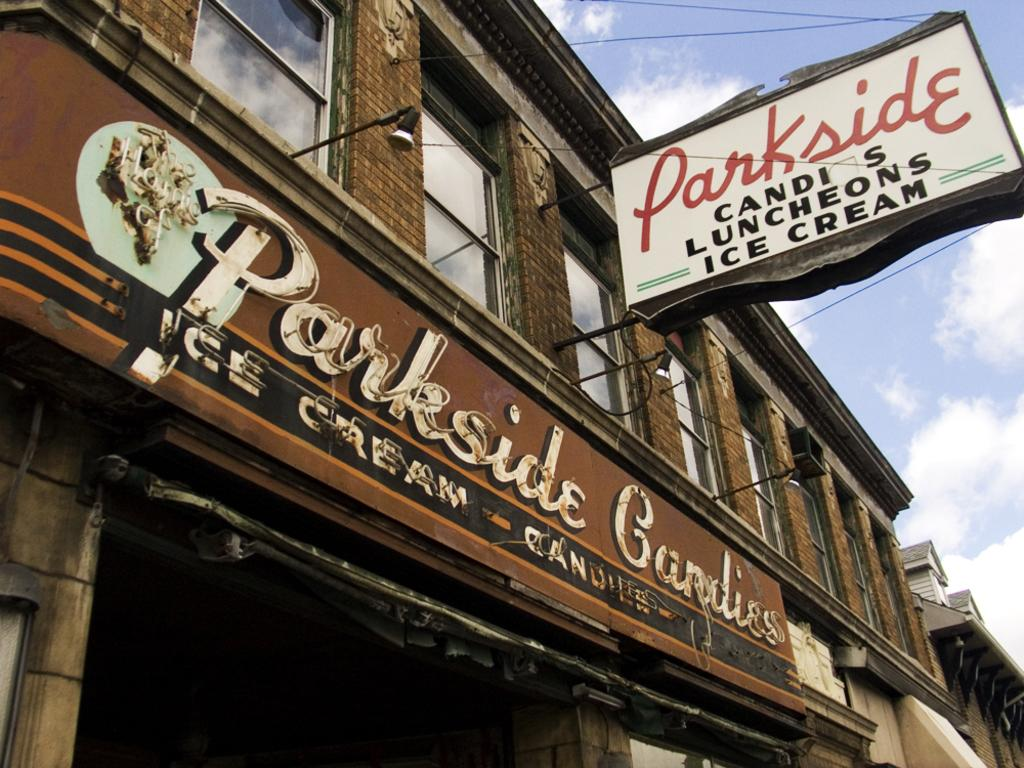What type of structures can be seen in the image? There are buildings in the image. Can you describe a specific building in the image? There is a building with windows in the image. What is attached to the building? There are posters attached to the building. How are the posters in the image? The posters are highlighted. What is visible in the background of the image? The sky is visible in the image. What can be seen in the sky? Clouds are present in the sky. What type of creature is featured in the advertisement on the poster? There is no advertisement or creature present on the posters in the image; they are highlighted but do not contain any images or text related to a creature. 